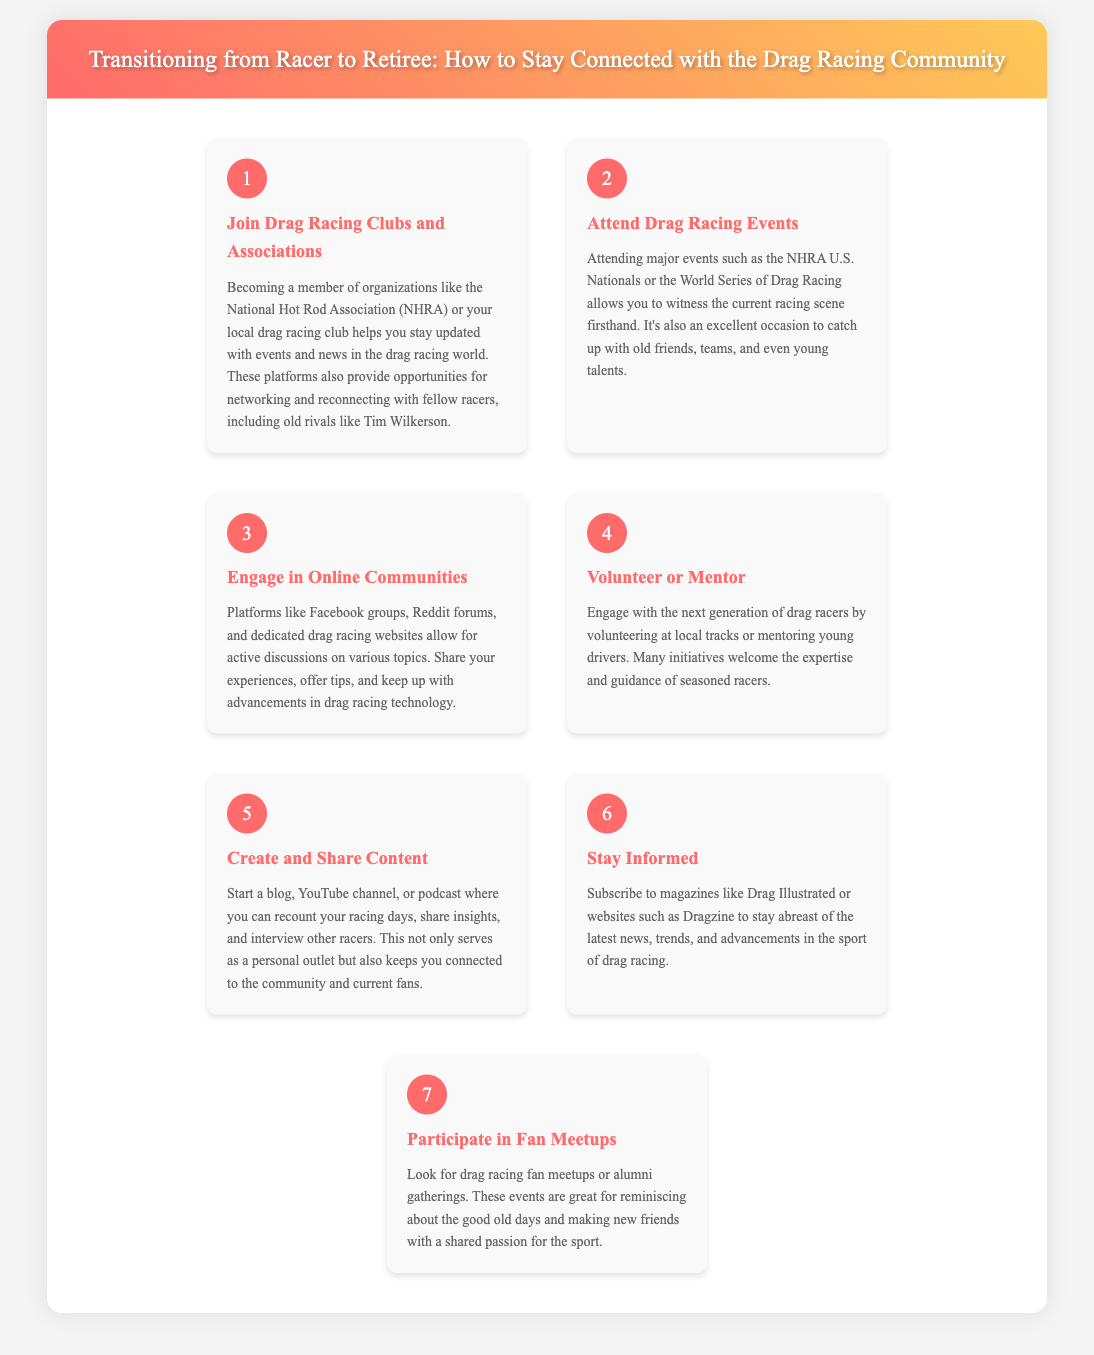What is the first step to stay connected? The first step mentioned in the infographic is to join drag racing clubs and associations.
Answer: Join Drag Racing Clubs and Associations How many steps are outlined in the infographic? The infographic outlines a total of seven steps for transitioning from racer to retiree.
Answer: 7 Which organization is suggested for membership? The document suggests becoming a member of organizations like the National Hot Rod Association (NHRA).
Answer: NHRA What can engaging in online communities help with? Engaging in online communities allows for active discussions on various drag racing topics.
Answer: Active discussions What is one way to contribute to the next generation of racers? One way to contribute is by volunteering at local tracks or mentoring young drivers.
Answer: Volunteer or Mentor What type of content can be created to stay connected? The infographic suggests starting a blog, YouTube channel, or podcast to share experiences.
Answer: Blog, YouTube channel, or podcast Which publication is recommended for staying informed? A recommended publication to subscribe to is Drag Illustrated.
Answer: Drag Illustrated What can fan meetups provide? Fan meetups are great for reminiscing about the good old days and making new friends.
Answer: Reminiscing and making new friends 